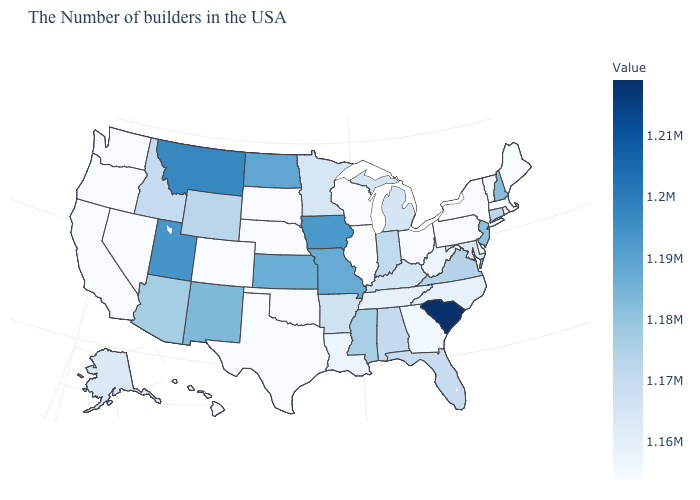Does the map have missing data?
Answer briefly. No. Among the states that border Montana , which have the lowest value?
Keep it brief. South Dakota. Which states have the highest value in the USA?
Quick response, please. South Carolina. Which states have the lowest value in the USA?
Keep it brief. Maine, Massachusetts, Rhode Island, Vermont, New York, Delaware, Pennsylvania, Ohio, Wisconsin, Illinois, Nebraska, Oklahoma, Texas, South Dakota, Colorado, Nevada, California, Washington, Oregon, Hawaii. Does South Carolina have the highest value in the USA?
Short answer required. Yes. 